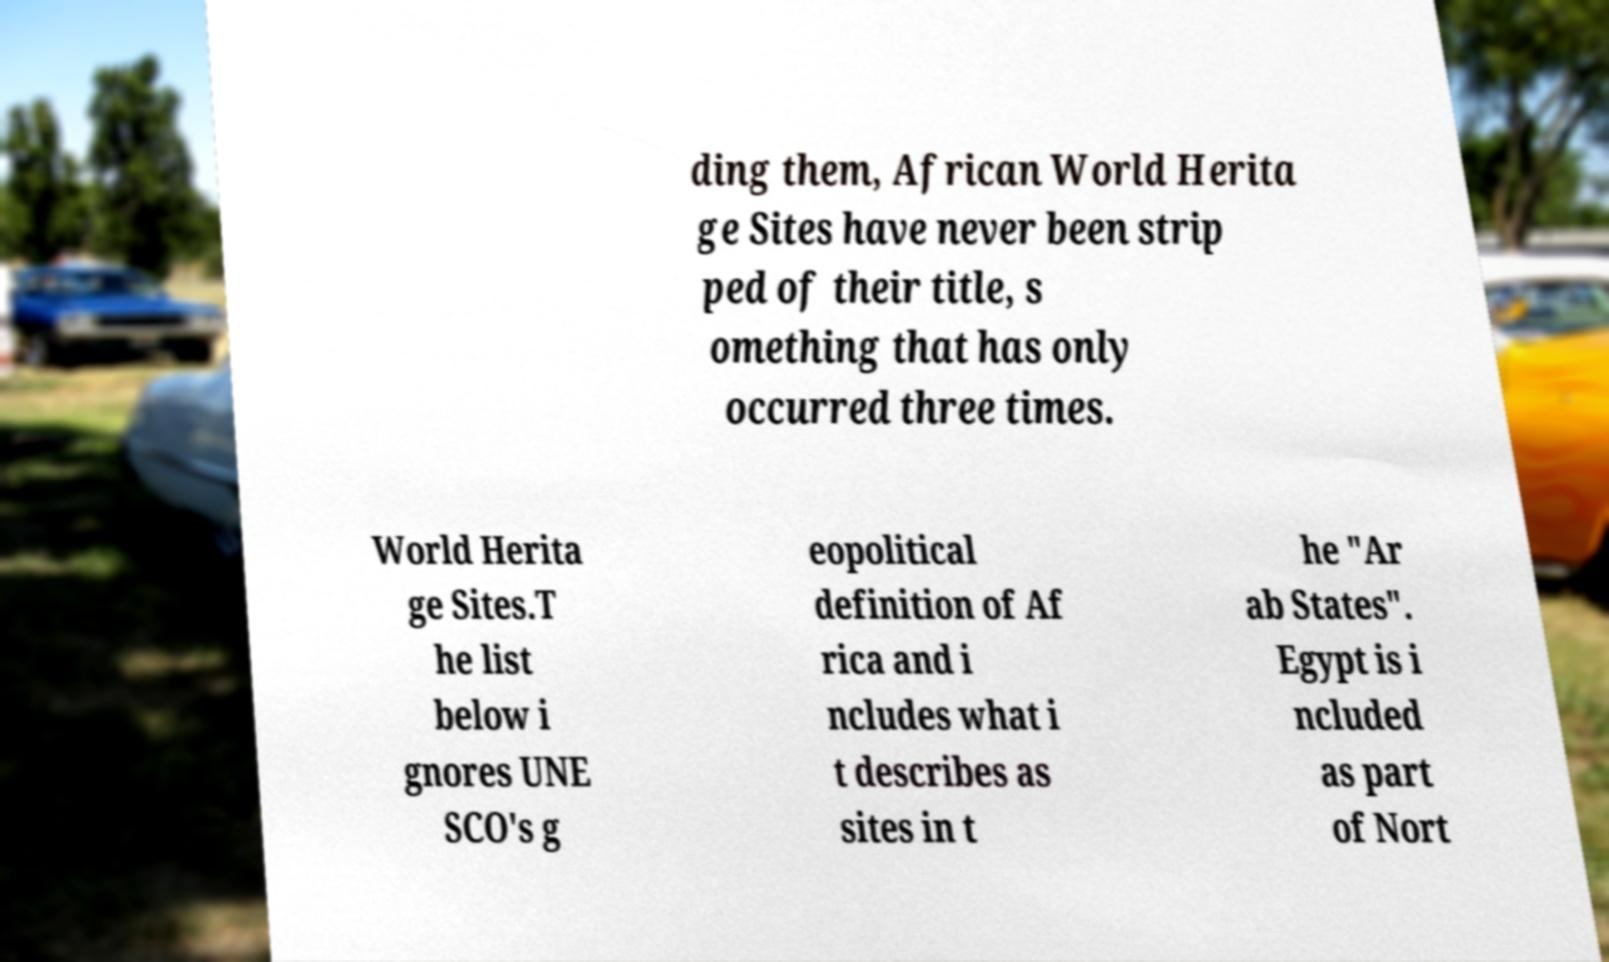Could you extract and type out the text from this image? ding them, African World Herita ge Sites have never been strip ped of their title, s omething that has only occurred three times. World Herita ge Sites.T he list below i gnores UNE SCO's g eopolitical definition of Af rica and i ncludes what i t describes as sites in t he "Ar ab States". Egypt is i ncluded as part of Nort 